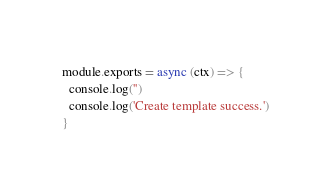<code> <loc_0><loc_0><loc_500><loc_500><_JavaScript_>module.exports = async (ctx) => {
  console.log('')
  console.log('Create template success.')
}
</code> 